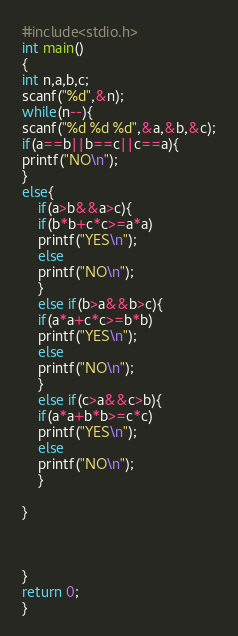<code> <loc_0><loc_0><loc_500><loc_500><_C++_>#include<stdio.h>
int main()
{
int n,a,b,c;
scanf("%d",&n);
while(n--){
scanf("%d %d %d",&a,&b,&c);
if(a==b||b==c||c==a){
printf("NO\n");
}
else{
    if(a>b&&a>c){
    if(b*b+c*c>=a*a)
    printf("YES\n");
    else
    printf("NO\n");
    }
    else if(b>a&&b>c){
    if(a*a+c*c>=b*b)
    printf("YES\n");
    else
    printf("NO\n");
    }
    else if(c>a&&c>b){
    if(a*a+b*b>=c*c)
    printf("YES\n");
    else
    printf("NO\n");
    }

}



}
return 0;
}</code> 